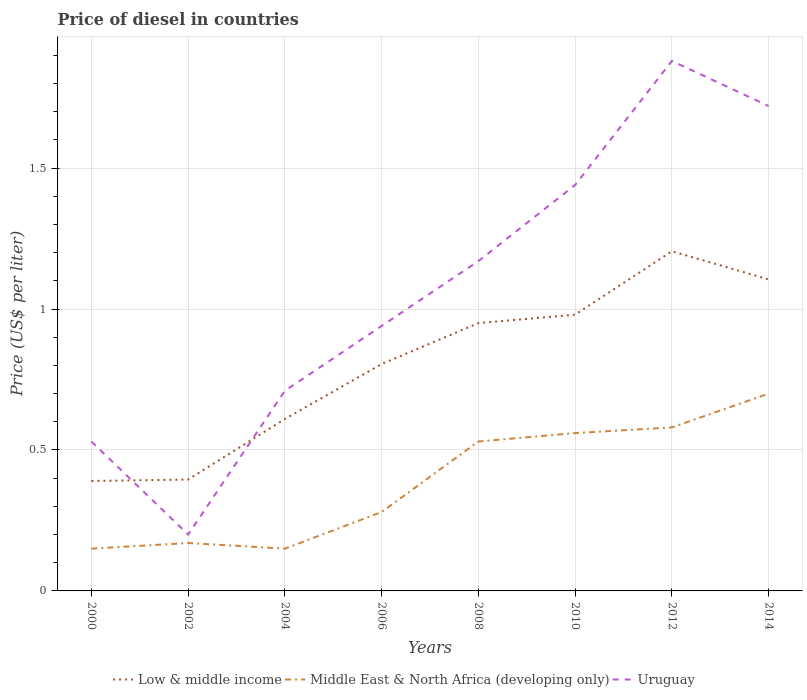How many different coloured lines are there?
Provide a succinct answer. 3. Does the line corresponding to Uruguay intersect with the line corresponding to Low & middle income?
Ensure brevity in your answer.  Yes. In which year was the price of diesel in Low & middle income maximum?
Ensure brevity in your answer.  2000. What is the total price of diesel in Uruguay in the graph?
Keep it short and to the point. -1.24. What is the difference between the highest and the second highest price of diesel in Middle East & North Africa (developing only)?
Your answer should be compact. 0.55. What is the difference between the highest and the lowest price of diesel in Uruguay?
Provide a short and direct response. 4. Is the price of diesel in Uruguay strictly greater than the price of diesel in Low & middle income over the years?
Your response must be concise. No. How many lines are there?
Provide a succinct answer. 3. What is the difference between two consecutive major ticks on the Y-axis?
Your response must be concise. 0.5. Are the values on the major ticks of Y-axis written in scientific E-notation?
Your response must be concise. No. Does the graph contain grids?
Give a very brief answer. Yes. Where does the legend appear in the graph?
Make the answer very short. Bottom center. How many legend labels are there?
Your response must be concise. 3. What is the title of the graph?
Your answer should be very brief. Price of diesel in countries. Does "Chile" appear as one of the legend labels in the graph?
Keep it short and to the point. No. What is the label or title of the Y-axis?
Provide a short and direct response. Price (US$ per liter). What is the Price (US$ per liter) of Low & middle income in 2000?
Keep it short and to the point. 0.39. What is the Price (US$ per liter) in Uruguay in 2000?
Your answer should be very brief. 0.53. What is the Price (US$ per liter) of Low & middle income in 2002?
Your answer should be very brief. 0.4. What is the Price (US$ per liter) in Middle East & North Africa (developing only) in 2002?
Your answer should be compact. 0.17. What is the Price (US$ per liter) in Low & middle income in 2004?
Keep it short and to the point. 0.61. What is the Price (US$ per liter) of Uruguay in 2004?
Offer a very short reply. 0.71. What is the Price (US$ per liter) in Low & middle income in 2006?
Keep it short and to the point. 0.81. What is the Price (US$ per liter) in Middle East & North Africa (developing only) in 2006?
Offer a very short reply. 0.28. What is the Price (US$ per liter) in Middle East & North Africa (developing only) in 2008?
Offer a very short reply. 0.53. What is the Price (US$ per liter) of Uruguay in 2008?
Keep it short and to the point. 1.17. What is the Price (US$ per liter) in Middle East & North Africa (developing only) in 2010?
Your answer should be very brief. 0.56. What is the Price (US$ per liter) in Uruguay in 2010?
Provide a succinct answer. 1.44. What is the Price (US$ per liter) in Low & middle income in 2012?
Provide a short and direct response. 1.21. What is the Price (US$ per liter) in Middle East & North Africa (developing only) in 2012?
Offer a terse response. 0.58. What is the Price (US$ per liter) of Uruguay in 2012?
Make the answer very short. 1.88. What is the Price (US$ per liter) of Low & middle income in 2014?
Offer a very short reply. 1.1. What is the Price (US$ per liter) of Uruguay in 2014?
Give a very brief answer. 1.72. Across all years, what is the maximum Price (US$ per liter) in Low & middle income?
Provide a short and direct response. 1.21. Across all years, what is the maximum Price (US$ per liter) in Uruguay?
Keep it short and to the point. 1.88. Across all years, what is the minimum Price (US$ per liter) of Low & middle income?
Offer a very short reply. 0.39. Across all years, what is the minimum Price (US$ per liter) of Uruguay?
Give a very brief answer. 0.2. What is the total Price (US$ per liter) of Low & middle income in the graph?
Ensure brevity in your answer.  6.44. What is the total Price (US$ per liter) of Middle East & North Africa (developing only) in the graph?
Your answer should be compact. 3.12. What is the total Price (US$ per liter) in Uruguay in the graph?
Give a very brief answer. 8.59. What is the difference between the Price (US$ per liter) in Low & middle income in 2000 and that in 2002?
Offer a terse response. -0.01. What is the difference between the Price (US$ per liter) of Middle East & North Africa (developing only) in 2000 and that in 2002?
Offer a terse response. -0.02. What is the difference between the Price (US$ per liter) in Uruguay in 2000 and that in 2002?
Provide a short and direct response. 0.33. What is the difference between the Price (US$ per liter) of Low & middle income in 2000 and that in 2004?
Your answer should be very brief. -0.22. What is the difference between the Price (US$ per liter) in Middle East & North Africa (developing only) in 2000 and that in 2004?
Make the answer very short. 0. What is the difference between the Price (US$ per liter) in Uruguay in 2000 and that in 2004?
Make the answer very short. -0.18. What is the difference between the Price (US$ per liter) in Low & middle income in 2000 and that in 2006?
Your response must be concise. -0.41. What is the difference between the Price (US$ per liter) of Middle East & North Africa (developing only) in 2000 and that in 2006?
Offer a terse response. -0.13. What is the difference between the Price (US$ per liter) of Uruguay in 2000 and that in 2006?
Provide a short and direct response. -0.41. What is the difference between the Price (US$ per liter) in Low & middle income in 2000 and that in 2008?
Provide a succinct answer. -0.56. What is the difference between the Price (US$ per liter) in Middle East & North Africa (developing only) in 2000 and that in 2008?
Your answer should be compact. -0.38. What is the difference between the Price (US$ per liter) of Uruguay in 2000 and that in 2008?
Your answer should be compact. -0.64. What is the difference between the Price (US$ per liter) of Low & middle income in 2000 and that in 2010?
Give a very brief answer. -0.59. What is the difference between the Price (US$ per liter) in Middle East & North Africa (developing only) in 2000 and that in 2010?
Your response must be concise. -0.41. What is the difference between the Price (US$ per liter) of Uruguay in 2000 and that in 2010?
Your answer should be very brief. -0.91. What is the difference between the Price (US$ per liter) of Low & middle income in 2000 and that in 2012?
Keep it short and to the point. -0.81. What is the difference between the Price (US$ per liter) of Middle East & North Africa (developing only) in 2000 and that in 2012?
Your response must be concise. -0.43. What is the difference between the Price (US$ per liter) of Uruguay in 2000 and that in 2012?
Ensure brevity in your answer.  -1.35. What is the difference between the Price (US$ per liter) in Low & middle income in 2000 and that in 2014?
Provide a short and direct response. -0.71. What is the difference between the Price (US$ per liter) of Middle East & North Africa (developing only) in 2000 and that in 2014?
Give a very brief answer. -0.55. What is the difference between the Price (US$ per liter) of Uruguay in 2000 and that in 2014?
Offer a terse response. -1.19. What is the difference between the Price (US$ per liter) of Low & middle income in 2002 and that in 2004?
Provide a short and direct response. -0.21. What is the difference between the Price (US$ per liter) of Uruguay in 2002 and that in 2004?
Give a very brief answer. -0.51. What is the difference between the Price (US$ per liter) in Low & middle income in 2002 and that in 2006?
Provide a succinct answer. -0.41. What is the difference between the Price (US$ per liter) in Middle East & North Africa (developing only) in 2002 and that in 2006?
Offer a very short reply. -0.11. What is the difference between the Price (US$ per liter) of Uruguay in 2002 and that in 2006?
Your answer should be very brief. -0.74. What is the difference between the Price (US$ per liter) in Low & middle income in 2002 and that in 2008?
Your response must be concise. -0.56. What is the difference between the Price (US$ per liter) in Middle East & North Africa (developing only) in 2002 and that in 2008?
Keep it short and to the point. -0.36. What is the difference between the Price (US$ per liter) in Uruguay in 2002 and that in 2008?
Offer a very short reply. -0.97. What is the difference between the Price (US$ per liter) of Low & middle income in 2002 and that in 2010?
Your answer should be very brief. -0.58. What is the difference between the Price (US$ per liter) in Middle East & North Africa (developing only) in 2002 and that in 2010?
Your answer should be compact. -0.39. What is the difference between the Price (US$ per liter) in Uruguay in 2002 and that in 2010?
Your answer should be compact. -1.24. What is the difference between the Price (US$ per liter) of Low & middle income in 2002 and that in 2012?
Keep it short and to the point. -0.81. What is the difference between the Price (US$ per liter) in Middle East & North Africa (developing only) in 2002 and that in 2012?
Your answer should be very brief. -0.41. What is the difference between the Price (US$ per liter) of Uruguay in 2002 and that in 2012?
Your response must be concise. -1.68. What is the difference between the Price (US$ per liter) of Low & middle income in 2002 and that in 2014?
Ensure brevity in your answer.  -0.71. What is the difference between the Price (US$ per liter) of Middle East & North Africa (developing only) in 2002 and that in 2014?
Ensure brevity in your answer.  -0.53. What is the difference between the Price (US$ per liter) of Uruguay in 2002 and that in 2014?
Offer a very short reply. -1.52. What is the difference between the Price (US$ per liter) in Low & middle income in 2004 and that in 2006?
Your answer should be very brief. -0.2. What is the difference between the Price (US$ per liter) of Middle East & North Africa (developing only) in 2004 and that in 2006?
Provide a succinct answer. -0.13. What is the difference between the Price (US$ per liter) of Uruguay in 2004 and that in 2006?
Offer a very short reply. -0.23. What is the difference between the Price (US$ per liter) of Low & middle income in 2004 and that in 2008?
Your answer should be compact. -0.34. What is the difference between the Price (US$ per liter) in Middle East & North Africa (developing only) in 2004 and that in 2008?
Give a very brief answer. -0.38. What is the difference between the Price (US$ per liter) in Uruguay in 2004 and that in 2008?
Offer a very short reply. -0.46. What is the difference between the Price (US$ per liter) in Low & middle income in 2004 and that in 2010?
Offer a very short reply. -0.37. What is the difference between the Price (US$ per liter) in Middle East & North Africa (developing only) in 2004 and that in 2010?
Offer a very short reply. -0.41. What is the difference between the Price (US$ per liter) in Uruguay in 2004 and that in 2010?
Offer a very short reply. -0.73. What is the difference between the Price (US$ per liter) of Low & middle income in 2004 and that in 2012?
Offer a very short reply. -0.59. What is the difference between the Price (US$ per liter) of Middle East & North Africa (developing only) in 2004 and that in 2012?
Give a very brief answer. -0.43. What is the difference between the Price (US$ per liter) of Uruguay in 2004 and that in 2012?
Your response must be concise. -1.17. What is the difference between the Price (US$ per liter) in Low & middle income in 2004 and that in 2014?
Make the answer very short. -0.49. What is the difference between the Price (US$ per liter) in Middle East & North Africa (developing only) in 2004 and that in 2014?
Your answer should be compact. -0.55. What is the difference between the Price (US$ per liter) in Uruguay in 2004 and that in 2014?
Your answer should be very brief. -1.01. What is the difference between the Price (US$ per liter) in Low & middle income in 2006 and that in 2008?
Your response must be concise. -0.14. What is the difference between the Price (US$ per liter) in Middle East & North Africa (developing only) in 2006 and that in 2008?
Provide a short and direct response. -0.25. What is the difference between the Price (US$ per liter) of Uruguay in 2006 and that in 2008?
Give a very brief answer. -0.23. What is the difference between the Price (US$ per liter) of Low & middle income in 2006 and that in 2010?
Provide a succinct answer. -0.17. What is the difference between the Price (US$ per liter) of Middle East & North Africa (developing only) in 2006 and that in 2010?
Provide a succinct answer. -0.28. What is the difference between the Price (US$ per liter) in Low & middle income in 2006 and that in 2012?
Offer a very short reply. -0.4. What is the difference between the Price (US$ per liter) in Uruguay in 2006 and that in 2012?
Offer a very short reply. -0.94. What is the difference between the Price (US$ per liter) in Middle East & North Africa (developing only) in 2006 and that in 2014?
Give a very brief answer. -0.42. What is the difference between the Price (US$ per liter) in Uruguay in 2006 and that in 2014?
Make the answer very short. -0.78. What is the difference between the Price (US$ per liter) of Low & middle income in 2008 and that in 2010?
Provide a succinct answer. -0.03. What is the difference between the Price (US$ per liter) in Middle East & North Africa (developing only) in 2008 and that in 2010?
Your answer should be compact. -0.03. What is the difference between the Price (US$ per liter) of Uruguay in 2008 and that in 2010?
Your response must be concise. -0.27. What is the difference between the Price (US$ per liter) in Low & middle income in 2008 and that in 2012?
Provide a succinct answer. -0.26. What is the difference between the Price (US$ per liter) of Uruguay in 2008 and that in 2012?
Give a very brief answer. -0.71. What is the difference between the Price (US$ per liter) in Low & middle income in 2008 and that in 2014?
Your response must be concise. -0.15. What is the difference between the Price (US$ per liter) in Middle East & North Africa (developing only) in 2008 and that in 2014?
Offer a terse response. -0.17. What is the difference between the Price (US$ per liter) in Uruguay in 2008 and that in 2014?
Make the answer very short. -0.55. What is the difference between the Price (US$ per liter) of Low & middle income in 2010 and that in 2012?
Give a very brief answer. -0.23. What is the difference between the Price (US$ per liter) of Middle East & North Africa (developing only) in 2010 and that in 2012?
Keep it short and to the point. -0.02. What is the difference between the Price (US$ per liter) of Uruguay in 2010 and that in 2012?
Ensure brevity in your answer.  -0.44. What is the difference between the Price (US$ per liter) in Low & middle income in 2010 and that in 2014?
Give a very brief answer. -0.12. What is the difference between the Price (US$ per liter) of Middle East & North Africa (developing only) in 2010 and that in 2014?
Give a very brief answer. -0.14. What is the difference between the Price (US$ per liter) in Uruguay in 2010 and that in 2014?
Your answer should be very brief. -0.28. What is the difference between the Price (US$ per liter) in Low & middle income in 2012 and that in 2014?
Ensure brevity in your answer.  0.1. What is the difference between the Price (US$ per liter) in Middle East & North Africa (developing only) in 2012 and that in 2014?
Offer a very short reply. -0.12. What is the difference between the Price (US$ per liter) of Uruguay in 2012 and that in 2014?
Keep it short and to the point. 0.16. What is the difference between the Price (US$ per liter) in Low & middle income in 2000 and the Price (US$ per liter) in Middle East & North Africa (developing only) in 2002?
Offer a very short reply. 0.22. What is the difference between the Price (US$ per liter) in Low & middle income in 2000 and the Price (US$ per liter) in Uruguay in 2002?
Ensure brevity in your answer.  0.19. What is the difference between the Price (US$ per liter) of Middle East & North Africa (developing only) in 2000 and the Price (US$ per liter) of Uruguay in 2002?
Keep it short and to the point. -0.05. What is the difference between the Price (US$ per liter) of Low & middle income in 2000 and the Price (US$ per liter) of Middle East & North Africa (developing only) in 2004?
Provide a short and direct response. 0.24. What is the difference between the Price (US$ per liter) of Low & middle income in 2000 and the Price (US$ per liter) of Uruguay in 2004?
Offer a terse response. -0.32. What is the difference between the Price (US$ per liter) of Middle East & North Africa (developing only) in 2000 and the Price (US$ per liter) of Uruguay in 2004?
Offer a terse response. -0.56. What is the difference between the Price (US$ per liter) of Low & middle income in 2000 and the Price (US$ per liter) of Middle East & North Africa (developing only) in 2006?
Your answer should be very brief. 0.11. What is the difference between the Price (US$ per liter) in Low & middle income in 2000 and the Price (US$ per liter) in Uruguay in 2006?
Provide a short and direct response. -0.55. What is the difference between the Price (US$ per liter) of Middle East & North Africa (developing only) in 2000 and the Price (US$ per liter) of Uruguay in 2006?
Give a very brief answer. -0.79. What is the difference between the Price (US$ per liter) of Low & middle income in 2000 and the Price (US$ per liter) of Middle East & North Africa (developing only) in 2008?
Provide a short and direct response. -0.14. What is the difference between the Price (US$ per liter) in Low & middle income in 2000 and the Price (US$ per liter) in Uruguay in 2008?
Give a very brief answer. -0.78. What is the difference between the Price (US$ per liter) in Middle East & North Africa (developing only) in 2000 and the Price (US$ per liter) in Uruguay in 2008?
Offer a terse response. -1.02. What is the difference between the Price (US$ per liter) of Low & middle income in 2000 and the Price (US$ per liter) of Middle East & North Africa (developing only) in 2010?
Offer a terse response. -0.17. What is the difference between the Price (US$ per liter) of Low & middle income in 2000 and the Price (US$ per liter) of Uruguay in 2010?
Your response must be concise. -1.05. What is the difference between the Price (US$ per liter) in Middle East & North Africa (developing only) in 2000 and the Price (US$ per liter) in Uruguay in 2010?
Provide a succinct answer. -1.29. What is the difference between the Price (US$ per liter) of Low & middle income in 2000 and the Price (US$ per liter) of Middle East & North Africa (developing only) in 2012?
Ensure brevity in your answer.  -0.19. What is the difference between the Price (US$ per liter) of Low & middle income in 2000 and the Price (US$ per liter) of Uruguay in 2012?
Provide a short and direct response. -1.49. What is the difference between the Price (US$ per liter) in Middle East & North Africa (developing only) in 2000 and the Price (US$ per liter) in Uruguay in 2012?
Give a very brief answer. -1.73. What is the difference between the Price (US$ per liter) in Low & middle income in 2000 and the Price (US$ per liter) in Middle East & North Africa (developing only) in 2014?
Make the answer very short. -0.31. What is the difference between the Price (US$ per liter) in Low & middle income in 2000 and the Price (US$ per liter) in Uruguay in 2014?
Provide a succinct answer. -1.33. What is the difference between the Price (US$ per liter) in Middle East & North Africa (developing only) in 2000 and the Price (US$ per liter) in Uruguay in 2014?
Your answer should be compact. -1.57. What is the difference between the Price (US$ per liter) in Low & middle income in 2002 and the Price (US$ per liter) in Middle East & North Africa (developing only) in 2004?
Your answer should be compact. 0.24. What is the difference between the Price (US$ per liter) of Low & middle income in 2002 and the Price (US$ per liter) of Uruguay in 2004?
Offer a very short reply. -0.32. What is the difference between the Price (US$ per liter) of Middle East & North Africa (developing only) in 2002 and the Price (US$ per liter) of Uruguay in 2004?
Keep it short and to the point. -0.54. What is the difference between the Price (US$ per liter) of Low & middle income in 2002 and the Price (US$ per liter) of Middle East & North Africa (developing only) in 2006?
Your answer should be very brief. 0.12. What is the difference between the Price (US$ per liter) in Low & middle income in 2002 and the Price (US$ per liter) in Uruguay in 2006?
Ensure brevity in your answer.  -0.55. What is the difference between the Price (US$ per liter) of Middle East & North Africa (developing only) in 2002 and the Price (US$ per liter) of Uruguay in 2006?
Provide a succinct answer. -0.77. What is the difference between the Price (US$ per liter) in Low & middle income in 2002 and the Price (US$ per liter) in Middle East & North Africa (developing only) in 2008?
Make the answer very short. -0.14. What is the difference between the Price (US$ per liter) in Low & middle income in 2002 and the Price (US$ per liter) in Uruguay in 2008?
Give a very brief answer. -0.78. What is the difference between the Price (US$ per liter) in Low & middle income in 2002 and the Price (US$ per liter) in Middle East & North Africa (developing only) in 2010?
Your response must be concise. -0.17. What is the difference between the Price (US$ per liter) in Low & middle income in 2002 and the Price (US$ per liter) in Uruguay in 2010?
Give a very brief answer. -1.04. What is the difference between the Price (US$ per liter) in Middle East & North Africa (developing only) in 2002 and the Price (US$ per liter) in Uruguay in 2010?
Your response must be concise. -1.27. What is the difference between the Price (US$ per liter) of Low & middle income in 2002 and the Price (US$ per liter) of Middle East & North Africa (developing only) in 2012?
Offer a terse response. -0.18. What is the difference between the Price (US$ per liter) in Low & middle income in 2002 and the Price (US$ per liter) in Uruguay in 2012?
Provide a succinct answer. -1.49. What is the difference between the Price (US$ per liter) of Middle East & North Africa (developing only) in 2002 and the Price (US$ per liter) of Uruguay in 2012?
Offer a very short reply. -1.71. What is the difference between the Price (US$ per liter) in Low & middle income in 2002 and the Price (US$ per liter) in Middle East & North Africa (developing only) in 2014?
Ensure brevity in your answer.  -0.3. What is the difference between the Price (US$ per liter) in Low & middle income in 2002 and the Price (US$ per liter) in Uruguay in 2014?
Provide a short and direct response. -1.32. What is the difference between the Price (US$ per liter) in Middle East & North Africa (developing only) in 2002 and the Price (US$ per liter) in Uruguay in 2014?
Offer a terse response. -1.55. What is the difference between the Price (US$ per liter) in Low & middle income in 2004 and the Price (US$ per liter) in Middle East & North Africa (developing only) in 2006?
Make the answer very short. 0.33. What is the difference between the Price (US$ per liter) of Low & middle income in 2004 and the Price (US$ per liter) of Uruguay in 2006?
Your response must be concise. -0.33. What is the difference between the Price (US$ per liter) in Middle East & North Africa (developing only) in 2004 and the Price (US$ per liter) in Uruguay in 2006?
Ensure brevity in your answer.  -0.79. What is the difference between the Price (US$ per liter) of Low & middle income in 2004 and the Price (US$ per liter) of Middle East & North Africa (developing only) in 2008?
Offer a terse response. 0.08. What is the difference between the Price (US$ per liter) of Low & middle income in 2004 and the Price (US$ per liter) of Uruguay in 2008?
Make the answer very short. -0.56. What is the difference between the Price (US$ per liter) of Middle East & North Africa (developing only) in 2004 and the Price (US$ per liter) of Uruguay in 2008?
Offer a terse response. -1.02. What is the difference between the Price (US$ per liter) in Low & middle income in 2004 and the Price (US$ per liter) in Middle East & North Africa (developing only) in 2010?
Your response must be concise. 0.05. What is the difference between the Price (US$ per liter) in Low & middle income in 2004 and the Price (US$ per liter) in Uruguay in 2010?
Make the answer very short. -0.83. What is the difference between the Price (US$ per liter) in Middle East & North Africa (developing only) in 2004 and the Price (US$ per liter) in Uruguay in 2010?
Ensure brevity in your answer.  -1.29. What is the difference between the Price (US$ per liter) in Low & middle income in 2004 and the Price (US$ per liter) in Middle East & North Africa (developing only) in 2012?
Keep it short and to the point. 0.03. What is the difference between the Price (US$ per liter) of Low & middle income in 2004 and the Price (US$ per liter) of Uruguay in 2012?
Your answer should be compact. -1.27. What is the difference between the Price (US$ per liter) in Middle East & North Africa (developing only) in 2004 and the Price (US$ per liter) in Uruguay in 2012?
Offer a terse response. -1.73. What is the difference between the Price (US$ per liter) in Low & middle income in 2004 and the Price (US$ per liter) in Middle East & North Africa (developing only) in 2014?
Offer a very short reply. -0.09. What is the difference between the Price (US$ per liter) of Low & middle income in 2004 and the Price (US$ per liter) of Uruguay in 2014?
Your answer should be very brief. -1.11. What is the difference between the Price (US$ per liter) in Middle East & North Africa (developing only) in 2004 and the Price (US$ per liter) in Uruguay in 2014?
Give a very brief answer. -1.57. What is the difference between the Price (US$ per liter) in Low & middle income in 2006 and the Price (US$ per liter) in Middle East & North Africa (developing only) in 2008?
Your response must be concise. 0.28. What is the difference between the Price (US$ per liter) of Low & middle income in 2006 and the Price (US$ per liter) of Uruguay in 2008?
Keep it short and to the point. -0.36. What is the difference between the Price (US$ per liter) in Middle East & North Africa (developing only) in 2006 and the Price (US$ per liter) in Uruguay in 2008?
Provide a succinct answer. -0.89. What is the difference between the Price (US$ per liter) in Low & middle income in 2006 and the Price (US$ per liter) in Middle East & North Africa (developing only) in 2010?
Your answer should be very brief. 0.24. What is the difference between the Price (US$ per liter) of Low & middle income in 2006 and the Price (US$ per liter) of Uruguay in 2010?
Give a very brief answer. -0.64. What is the difference between the Price (US$ per liter) in Middle East & North Africa (developing only) in 2006 and the Price (US$ per liter) in Uruguay in 2010?
Your response must be concise. -1.16. What is the difference between the Price (US$ per liter) of Low & middle income in 2006 and the Price (US$ per liter) of Middle East & North Africa (developing only) in 2012?
Make the answer very short. 0.23. What is the difference between the Price (US$ per liter) of Low & middle income in 2006 and the Price (US$ per liter) of Uruguay in 2012?
Give a very brief answer. -1.07. What is the difference between the Price (US$ per liter) in Low & middle income in 2006 and the Price (US$ per liter) in Middle East & North Africa (developing only) in 2014?
Ensure brevity in your answer.  0.1. What is the difference between the Price (US$ per liter) in Low & middle income in 2006 and the Price (US$ per liter) in Uruguay in 2014?
Your response must be concise. -0.92. What is the difference between the Price (US$ per liter) in Middle East & North Africa (developing only) in 2006 and the Price (US$ per liter) in Uruguay in 2014?
Make the answer very short. -1.44. What is the difference between the Price (US$ per liter) in Low & middle income in 2008 and the Price (US$ per liter) in Middle East & North Africa (developing only) in 2010?
Keep it short and to the point. 0.39. What is the difference between the Price (US$ per liter) in Low & middle income in 2008 and the Price (US$ per liter) in Uruguay in 2010?
Offer a very short reply. -0.49. What is the difference between the Price (US$ per liter) in Middle East & North Africa (developing only) in 2008 and the Price (US$ per liter) in Uruguay in 2010?
Your answer should be compact. -0.91. What is the difference between the Price (US$ per liter) of Low & middle income in 2008 and the Price (US$ per liter) of Middle East & North Africa (developing only) in 2012?
Your answer should be very brief. 0.37. What is the difference between the Price (US$ per liter) in Low & middle income in 2008 and the Price (US$ per liter) in Uruguay in 2012?
Give a very brief answer. -0.93. What is the difference between the Price (US$ per liter) in Middle East & North Africa (developing only) in 2008 and the Price (US$ per liter) in Uruguay in 2012?
Ensure brevity in your answer.  -1.35. What is the difference between the Price (US$ per liter) of Low & middle income in 2008 and the Price (US$ per liter) of Middle East & North Africa (developing only) in 2014?
Offer a terse response. 0.25. What is the difference between the Price (US$ per liter) in Low & middle income in 2008 and the Price (US$ per liter) in Uruguay in 2014?
Keep it short and to the point. -0.77. What is the difference between the Price (US$ per liter) of Middle East & North Africa (developing only) in 2008 and the Price (US$ per liter) of Uruguay in 2014?
Your answer should be compact. -1.19. What is the difference between the Price (US$ per liter) in Low & middle income in 2010 and the Price (US$ per liter) in Middle East & North Africa (developing only) in 2012?
Provide a short and direct response. 0.4. What is the difference between the Price (US$ per liter) in Middle East & North Africa (developing only) in 2010 and the Price (US$ per liter) in Uruguay in 2012?
Give a very brief answer. -1.32. What is the difference between the Price (US$ per liter) in Low & middle income in 2010 and the Price (US$ per liter) in Middle East & North Africa (developing only) in 2014?
Provide a short and direct response. 0.28. What is the difference between the Price (US$ per liter) of Low & middle income in 2010 and the Price (US$ per liter) of Uruguay in 2014?
Your answer should be compact. -0.74. What is the difference between the Price (US$ per liter) in Middle East & North Africa (developing only) in 2010 and the Price (US$ per liter) in Uruguay in 2014?
Give a very brief answer. -1.16. What is the difference between the Price (US$ per liter) in Low & middle income in 2012 and the Price (US$ per liter) in Middle East & North Africa (developing only) in 2014?
Your answer should be very brief. 0.51. What is the difference between the Price (US$ per liter) in Low & middle income in 2012 and the Price (US$ per liter) in Uruguay in 2014?
Provide a succinct answer. -0.52. What is the difference between the Price (US$ per liter) of Middle East & North Africa (developing only) in 2012 and the Price (US$ per liter) of Uruguay in 2014?
Offer a terse response. -1.14. What is the average Price (US$ per liter) of Low & middle income per year?
Your response must be concise. 0.81. What is the average Price (US$ per liter) of Middle East & North Africa (developing only) per year?
Your answer should be very brief. 0.39. What is the average Price (US$ per liter) of Uruguay per year?
Provide a short and direct response. 1.07. In the year 2000, what is the difference between the Price (US$ per liter) of Low & middle income and Price (US$ per liter) of Middle East & North Africa (developing only)?
Provide a short and direct response. 0.24. In the year 2000, what is the difference between the Price (US$ per liter) in Low & middle income and Price (US$ per liter) in Uruguay?
Offer a terse response. -0.14. In the year 2000, what is the difference between the Price (US$ per liter) in Middle East & North Africa (developing only) and Price (US$ per liter) in Uruguay?
Ensure brevity in your answer.  -0.38. In the year 2002, what is the difference between the Price (US$ per liter) of Low & middle income and Price (US$ per liter) of Middle East & North Africa (developing only)?
Keep it short and to the point. 0.23. In the year 2002, what is the difference between the Price (US$ per liter) in Low & middle income and Price (US$ per liter) in Uruguay?
Your answer should be very brief. 0.2. In the year 2002, what is the difference between the Price (US$ per liter) in Middle East & North Africa (developing only) and Price (US$ per liter) in Uruguay?
Your answer should be compact. -0.03. In the year 2004, what is the difference between the Price (US$ per liter) in Low & middle income and Price (US$ per liter) in Middle East & North Africa (developing only)?
Offer a terse response. 0.46. In the year 2004, what is the difference between the Price (US$ per liter) in Middle East & North Africa (developing only) and Price (US$ per liter) in Uruguay?
Keep it short and to the point. -0.56. In the year 2006, what is the difference between the Price (US$ per liter) of Low & middle income and Price (US$ per liter) of Middle East & North Africa (developing only)?
Offer a very short reply. 0.53. In the year 2006, what is the difference between the Price (US$ per liter) of Low & middle income and Price (US$ per liter) of Uruguay?
Your answer should be compact. -0.14. In the year 2006, what is the difference between the Price (US$ per liter) of Middle East & North Africa (developing only) and Price (US$ per liter) of Uruguay?
Your answer should be compact. -0.66. In the year 2008, what is the difference between the Price (US$ per liter) of Low & middle income and Price (US$ per liter) of Middle East & North Africa (developing only)?
Make the answer very short. 0.42. In the year 2008, what is the difference between the Price (US$ per liter) in Low & middle income and Price (US$ per liter) in Uruguay?
Keep it short and to the point. -0.22. In the year 2008, what is the difference between the Price (US$ per liter) in Middle East & North Africa (developing only) and Price (US$ per liter) in Uruguay?
Offer a terse response. -0.64. In the year 2010, what is the difference between the Price (US$ per liter) in Low & middle income and Price (US$ per liter) in Middle East & North Africa (developing only)?
Give a very brief answer. 0.42. In the year 2010, what is the difference between the Price (US$ per liter) of Low & middle income and Price (US$ per liter) of Uruguay?
Provide a succinct answer. -0.46. In the year 2010, what is the difference between the Price (US$ per liter) in Middle East & North Africa (developing only) and Price (US$ per liter) in Uruguay?
Offer a very short reply. -0.88. In the year 2012, what is the difference between the Price (US$ per liter) of Low & middle income and Price (US$ per liter) of Uruguay?
Provide a short and direct response. -0.68. In the year 2012, what is the difference between the Price (US$ per liter) in Middle East & North Africa (developing only) and Price (US$ per liter) in Uruguay?
Give a very brief answer. -1.3. In the year 2014, what is the difference between the Price (US$ per liter) in Low & middle income and Price (US$ per liter) in Middle East & North Africa (developing only)?
Offer a terse response. 0.41. In the year 2014, what is the difference between the Price (US$ per liter) in Low & middle income and Price (US$ per liter) in Uruguay?
Your response must be concise. -0.61. In the year 2014, what is the difference between the Price (US$ per liter) in Middle East & North Africa (developing only) and Price (US$ per liter) in Uruguay?
Your answer should be compact. -1.02. What is the ratio of the Price (US$ per liter) of Low & middle income in 2000 to that in 2002?
Provide a succinct answer. 0.99. What is the ratio of the Price (US$ per liter) of Middle East & North Africa (developing only) in 2000 to that in 2002?
Provide a short and direct response. 0.88. What is the ratio of the Price (US$ per liter) in Uruguay in 2000 to that in 2002?
Offer a very short reply. 2.65. What is the ratio of the Price (US$ per liter) in Low & middle income in 2000 to that in 2004?
Ensure brevity in your answer.  0.64. What is the ratio of the Price (US$ per liter) in Uruguay in 2000 to that in 2004?
Make the answer very short. 0.75. What is the ratio of the Price (US$ per liter) in Low & middle income in 2000 to that in 2006?
Provide a succinct answer. 0.48. What is the ratio of the Price (US$ per liter) of Middle East & North Africa (developing only) in 2000 to that in 2006?
Your answer should be very brief. 0.54. What is the ratio of the Price (US$ per liter) in Uruguay in 2000 to that in 2006?
Give a very brief answer. 0.56. What is the ratio of the Price (US$ per liter) of Low & middle income in 2000 to that in 2008?
Provide a succinct answer. 0.41. What is the ratio of the Price (US$ per liter) in Middle East & North Africa (developing only) in 2000 to that in 2008?
Offer a very short reply. 0.28. What is the ratio of the Price (US$ per liter) of Uruguay in 2000 to that in 2008?
Make the answer very short. 0.45. What is the ratio of the Price (US$ per liter) in Low & middle income in 2000 to that in 2010?
Your answer should be very brief. 0.4. What is the ratio of the Price (US$ per liter) of Middle East & North Africa (developing only) in 2000 to that in 2010?
Offer a very short reply. 0.27. What is the ratio of the Price (US$ per liter) in Uruguay in 2000 to that in 2010?
Offer a very short reply. 0.37. What is the ratio of the Price (US$ per liter) of Low & middle income in 2000 to that in 2012?
Provide a short and direct response. 0.32. What is the ratio of the Price (US$ per liter) of Middle East & North Africa (developing only) in 2000 to that in 2012?
Offer a very short reply. 0.26. What is the ratio of the Price (US$ per liter) in Uruguay in 2000 to that in 2012?
Offer a terse response. 0.28. What is the ratio of the Price (US$ per liter) in Low & middle income in 2000 to that in 2014?
Provide a short and direct response. 0.35. What is the ratio of the Price (US$ per liter) in Middle East & North Africa (developing only) in 2000 to that in 2014?
Provide a short and direct response. 0.21. What is the ratio of the Price (US$ per liter) in Uruguay in 2000 to that in 2014?
Give a very brief answer. 0.31. What is the ratio of the Price (US$ per liter) of Low & middle income in 2002 to that in 2004?
Provide a short and direct response. 0.65. What is the ratio of the Price (US$ per liter) of Middle East & North Africa (developing only) in 2002 to that in 2004?
Offer a very short reply. 1.13. What is the ratio of the Price (US$ per liter) in Uruguay in 2002 to that in 2004?
Your answer should be very brief. 0.28. What is the ratio of the Price (US$ per liter) of Low & middle income in 2002 to that in 2006?
Offer a terse response. 0.49. What is the ratio of the Price (US$ per liter) in Middle East & North Africa (developing only) in 2002 to that in 2006?
Your answer should be compact. 0.61. What is the ratio of the Price (US$ per liter) in Uruguay in 2002 to that in 2006?
Keep it short and to the point. 0.21. What is the ratio of the Price (US$ per liter) of Low & middle income in 2002 to that in 2008?
Offer a terse response. 0.42. What is the ratio of the Price (US$ per liter) in Middle East & North Africa (developing only) in 2002 to that in 2008?
Make the answer very short. 0.32. What is the ratio of the Price (US$ per liter) of Uruguay in 2002 to that in 2008?
Make the answer very short. 0.17. What is the ratio of the Price (US$ per liter) of Low & middle income in 2002 to that in 2010?
Offer a very short reply. 0.4. What is the ratio of the Price (US$ per liter) in Middle East & North Africa (developing only) in 2002 to that in 2010?
Give a very brief answer. 0.3. What is the ratio of the Price (US$ per liter) in Uruguay in 2002 to that in 2010?
Keep it short and to the point. 0.14. What is the ratio of the Price (US$ per liter) of Low & middle income in 2002 to that in 2012?
Your answer should be compact. 0.33. What is the ratio of the Price (US$ per liter) in Middle East & North Africa (developing only) in 2002 to that in 2012?
Offer a terse response. 0.29. What is the ratio of the Price (US$ per liter) of Uruguay in 2002 to that in 2012?
Provide a succinct answer. 0.11. What is the ratio of the Price (US$ per liter) of Low & middle income in 2002 to that in 2014?
Keep it short and to the point. 0.36. What is the ratio of the Price (US$ per liter) in Middle East & North Africa (developing only) in 2002 to that in 2014?
Keep it short and to the point. 0.24. What is the ratio of the Price (US$ per liter) in Uruguay in 2002 to that in 2014?
Your response must be concise. 0.12. What is the ratio of the Price (US$ per liter) in Low & middle income in 2004 to that in 2006?
Provide a short and direct response. 0.76. What is the ratio of the Price (US$ per liter) in Middle East & North Africa (developing only) in 2004 to that in 2006?
Provide a short and direct response. 0.54. What is the ratio of the Price (US$ per liter) of Uruguay in 2004 to that in 2006?
Keep it short and to the point. 0.76. What is the ratio of the Price (US$ per liter) in Low & middle income in 2004 to that in 2008?
Keep it short and to the point. 0.64. What is the ratio of the Price (US$ per liter) of Middle East & North Africa (developing only) in 2004 to that in 2008?
Provide a short and direct response. 0.28. What is the ratio of the Price (US$ per liter) in Uruguay in 2004 to that in 2008?
Offer a terse response. 0.61. What is the ratio of the Price (US$ per liter) of Low & middle income in 2004 to that in 2010?
Offer a terse response. 0.62. What is the ratio of the Price (US$ per liter) in Middle East & North Africa (developing only) in 2004 to that in 2010?
Your response must be concise. 0.27. What is the ratio of the Price (US$ per liter) of Uruguay in 2004 to that in 2010?
Make the answer very short. 0.49. What is the ratio of the Price (US$ per liter) in Low & middle income in 2004 to that in 2012?
Offer a terse response. 0.51. What is the ratio of the Price (US$ per liter) of Middle East & North Africa (developing only) in 2004 to that in 2012?
Make the answer very short. 0.26. What is the ratio of the Price (US$ per liter) in Uruguay in 2004 to that in 2012?
Your response must be concise. 0.38. What is the ratio of the Price (US$ per liter) in Low & middle income in 2004 to that in 2014?
Your answer should be compact. 0.55. What is the ratio of the Price (US$ per liter) of Middle East & North Africa (developing only) in 2004 to that in 2014?
Offer a very short reply. 0.21. What is the ratio of the Price (US$ per liter) of Uruguay in 2004 to that in 2014?
Keep it short and to the point. 0.41. What is the ratio of the Price (US$ per liter) in Low & middle income in 2006 to that in 2008?
Ensure brevity in your answer.  0.85. What is the ratio of the Price (US$ per liter) of Middle East & North Africa (developing only) in 2006 to that in 2008?
Provide a succinct answer. 0.53. What is the ratio of the Price (US$ per liter) of Uruguay in 2006 to that in 2008?
Provide a short and direct response. 0.8. What is the ratio of the Price (US$ per liter) in Low & middle income in 2006 to that in 2010?
Give a very brief answer. 0.82. What is the ratio of the Price (US$ per liter) of Uruguay in 2006 to that in 2010?
Your answer should be compact. 0.65. What is the ratio of the Price (US$ per liter) of Low & middle income in 2006 to that in 2012?
Your answer should be very brief. 0.67. What is the ratio of the Price (US$ per liter) of Middle East & North Africa (developing only) in 2006 to that in 2012?
Provide a short and direct response. 0.48. What is the ratio of the Price (US$ per liter) of Low & middle income in 2006 to that in 2014?
Your answer should be very brief. 0.73. What is the ratio of the Price (US$ per liter) of Middle East & North Africa (developing only) in 2006 to that in 2014?
Provide a succinct answer. 0.4. What is the ratio of the Price (US$ per liter) in Uruguay in 2006 to that in 2014?
Keep it short and to the point. 0.55. What is the ratio of the Price (US$ per liter) in Low & middle income in 2008 to that in 2010?
Give a very brief answer. 0.97. What is the ratio of the Price (US$ per liter) in Middle East & North Africa (developing only) in 2008 to that in 2010?
Provide a succinct answer. 0.95. What is the ratio of the Price (US$ per liter) of Uruguay in 2008 to that in 2010?
Provide a succinct answer. 0.81. What is the ratio of the Price (US$ per liter) of Low & middle income in 2008 to that in 2012?
Your answer should be compact. 0.79. What is the ratio of the Price (US$ per liter) in Middle East & North Africa (developing only) in 2008 to that in 2012?
Give a very brief answer. 0.91. What is the ratio of the Price (US$ per liter) in Uruguay in 2008 to that in 2012?
Your answer should be compact. 0.62. What is the ratio of the Price (US$ per liter) of Low & middle income in 2008 to that in 2014?
Provide a short and direct response. 0.86. What is the ratio of the Price (US$ per liter) of Middle East & North Africa (developing only) in 2008 to that in 2014?
Your response must be concise. 0.76. What is the ratio of the Price (US$ per liter) of Uruguay in 2008 to that in 2014?
Ensure brevity in your answer.  0.68. What is the ratio of the Price (US$ per liter) of Low & middle income in 2010 to that in 2012?
Your answer should be very brief. 0.81. What is the ratio of the Price (US$ per liter) in Middle East & North Africa (developing only) in 2010 to that in 2012?
Your answer should be compact. 0.97. What is the ratio of the Price (US$ per liter) of Uruguay in 2010 to that in 2012?
Ensure brevity in your answer.  0.77. What is the ratio of the Price (US$ per liter) of Low & middle income in 2010 to that in 2014?
Offer a terse response. 0.89. What is the ratio of the Price (US$ per liter) in Middle East & North Africa (developing only) in 2010 to that in 2014?
Your answer should be very brief. 0.8. What is the ratio of the Price (US$ per liter) in Uruguay in 2010 to that in 2014?
Give a very brief answer. 0.84. What is the ratio of the Price (US$ per liter) of Low & middle income in 2012 to that in 2014?
Give a very brief answer. 1.09. What is the ratio of the Price (US$ per liter) in Middle East & North Africa (developing only) in 2012 to that in 2014?
Provide a short and direct response. 0.83. What is the ratio of the Price (US$ per liter) of Uruguay in 2012 to that in 2014?
Offer a terse response. 1.09. What is the difference between the highest and the second highest Price (US$ per liter) of Middle East & North Africa (developing only)?
Ensure brevity in your answer.  0.12. What is the difference between the highest and the second highest Price (US$ per liter) in Uruguay?
Keep it short and to the point. 0.16. What is the difference between the highest and the lowest Price (US$ per liter) of Low & middle income?
Provide a succinct answer. 0.81. What is the difference between the highest and the lowest Price (US$ per liter) of Middle East & North Africa (developing only)?
Keep it short and to the point. 0.55. What is the difference between the highest and the lowest Price (US$ per liter) in Uruguay?
Provide a succinct answer. 1.68. 